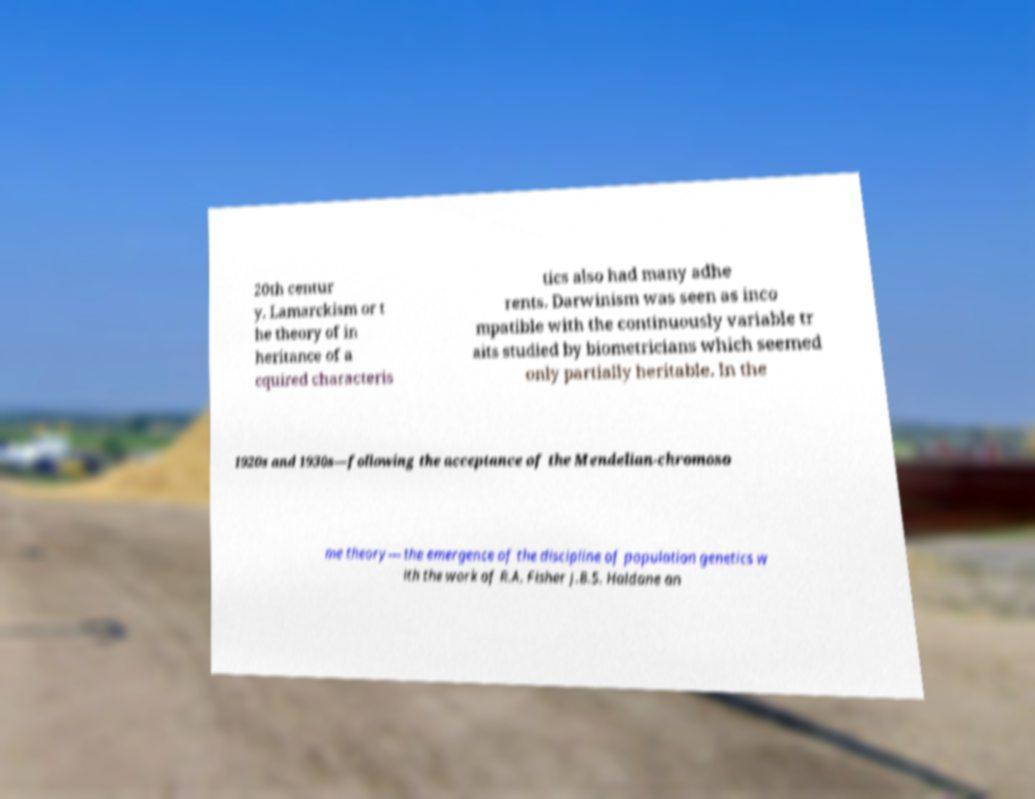There's text embedded in this image that I need extracted. Can you transcribe it verbatim? 20th centur y. Lamarckism or t he theory of in heritance of a cquired characteris tics also had many adhe rents. Darwinism was seen as inco mpatible with the continuously variable tr aits studied by biometricians which seemed only partially heritable. In the 1920s and 1930s—following the acceptance of the Mendelian-chromoso me theory— the emergence of the discipline of population genetics w ith the work of R.A. Fisher J.B.S. Haldane an 